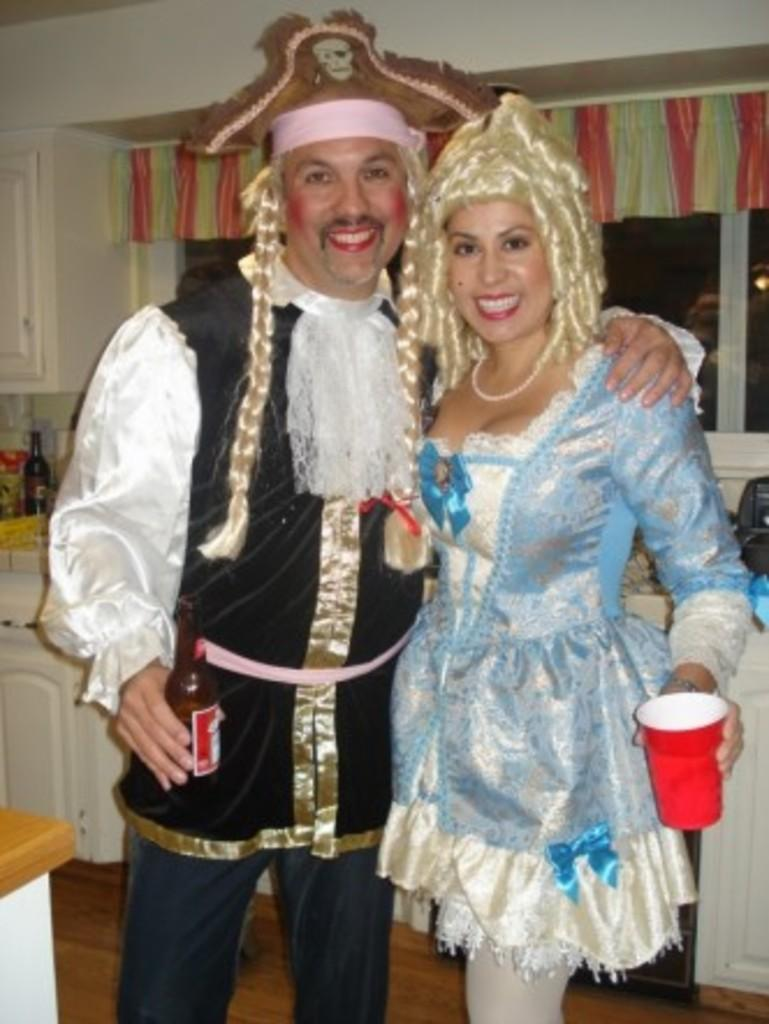How many people are present in the image? There are two people, a man and a woman, present in the image. What is the man holding in the image? The man is holding a beverage bottle. What is the woman holding in the image? The woman is holding a tumbler. What can be seen in the background of the image? There are cupboards, a wall, a window with a curtain, and a floor visible in the background of the image. How many minutes does it take for the pickle to grow in the image? There is no pickle present in the image, so it is not possible to determine how long it would take for a pickle to grow. 